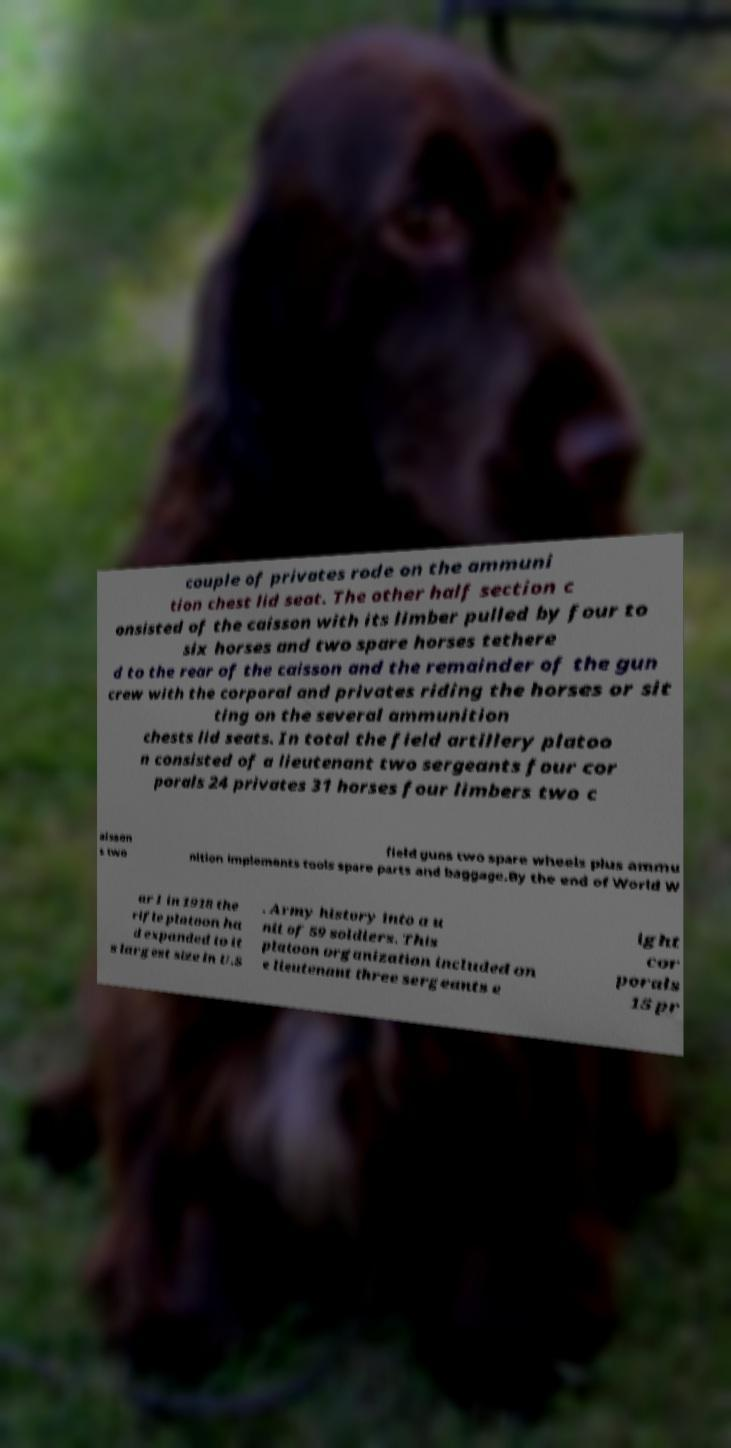For documentation purposes, I need the text within this image transcribed. Could you provide that? couple of privates rode on the ammuni tion chest lid seat. The other half section c onsisted of the caisson with its limber pulled by four to six horses and two spare horses tethere d to the rear of the caisson and the remainder of the gun crew with the corporal and privates riding the horses or sit ting on the several ammunition chests lid seats. In total the field artillery platoo n consisted of a lieutenant two sergeants four cor porals 24 privates 31 horses four limbers two c aisson s two field guns two spare wheels plus ammu nition implements tools spare parts and baggage.By the end of World W ar I in 1918 the rifle platoon ha d expanded to it s largest size in U.S . Army history into a u nit of 59 soldiers. This platoon organization included on e lieutenant three sergeants e ight cor porals 15 pr 